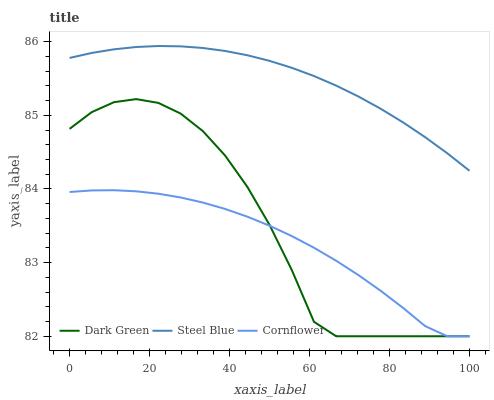Does Cornflower have the minimum area under the curve?
Answer yes or no. Yes. Does Steel Blue have the maximum area under the curve?
Answer yes or no. Yes. Does Dark Green have the minimum area under the curve?
Answer yes or no. No. Does Dark Green have the maximum area under the curve?
Answer yes or no. No. Is Steel Blue the smoothest?
Answer yes or no. Yes. Is Dark Green the roughest?
Answer yes or no. Yes. Is Dark Green the smoothest?
Answer yes or no. No. Is Steel Blue the roughest?
Answer yes or no. No. Does Cornflower have the lowest value?
Answer yes or no. Yes. Does Steel Blue have the lowest value?
Answer yes or no. No. Does Steel Blue have the highest value?
Answer yes or no. Yes. Does Dark Green have the highest value?
Answer yes or no. No. Is Dark Green less than Steel Blue?
Answer yes or no. Yes. Is Steel Blue greater than Cornflower?
Answer yes or no. Yes. Does Cornflower intersect Dark Green?
Answer yes or no. Yes. Is Cornflower less than Dark Green?
Answer yes or no. No. Is Cornflower greater than Dark Green?
Answer yes or no. No. Does Dark Green intersect Steel Blue?
Answer yes or no. No. 